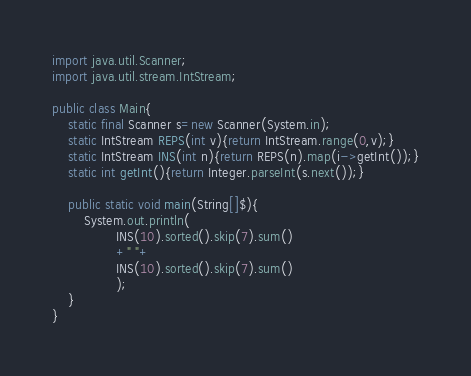Convert code to text. <code><loc_0><loc_0><loc_500><loc_500><_Java_>import java.util.Scanner;
import java.util.stream.IntStream;

public class Main{
	static final Scanner s=new Scanner(System.in);
	static IntStream REPS(int v){return IntStream.range(0,v);}
	static IntStream INS(int n){return REPS(n).map(i->getInt());}
	static int getInt(){return Integer.parseInt(s.next());}

	public static void main(String[]$){
		System.out.println(
				INS(10).sorted().skip(7).sum()
				+" "+
				INS(10).sorted().skip(7).sum()
				);
	}
}</code> 